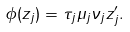<formula> <loc_0><loc_0><loc_500><loc_500>\phi ( z _ { j } ) = \tau _ { j } \mu _ { j } \nu _ { j } z ^ { \prime } _ { j } .</formula> 